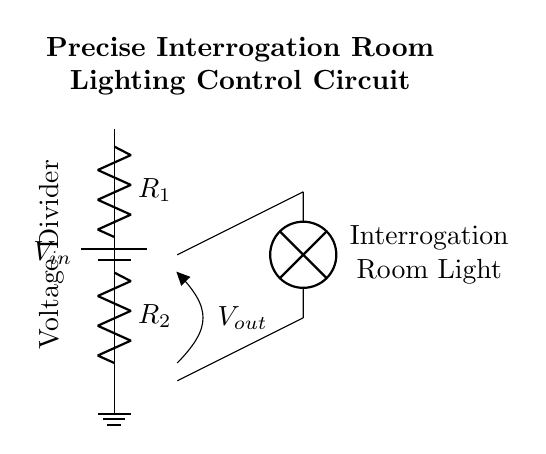What is the input voltage of this circuit? The input voltage is represented by the symbol V_in at the top of the circuit diagram, indicating it is the voltage supplied to the circuit.
Answer: V_in What are the resistor values in this circuit? The circuit shows two resistors labeled R_1 and R_2, but specific values are not provided in the diagram, hence we identify them by their symbols without numerical values.
Answer: R_1, R_2 What does the output voltage represent? The output voltage, labeled as V_out, indicates the voltage across R_2 which is used to control the light bulb in the interrogating room.
Answer: V_out How are the voltage divider resistors connected? R_1 is connected in series to R_2, forming a voltage divider configuration where the total voltage is divided across the resistors.
Answer: Series What is the function of the lamp in this circuit? The lamp is connected at the output, indicating it is powered by the divided voltage, providing illumination in the interrogation room based on the output voltage level.
Answer: Illumination What would happen if R_1 is increased? Increasing R_1 would decrease the output voltage V_out while keeping the input voltage V_in constant, leading to dimmer light from the lamp.
Answer: Decrease output voltage 